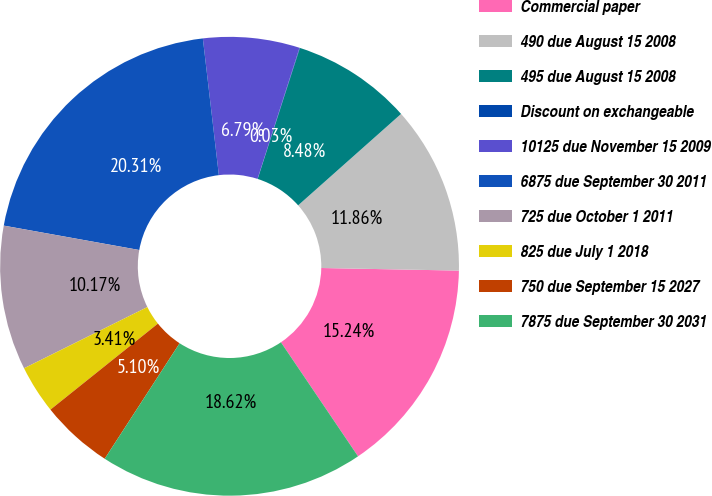<chart> <loc_0><loc_0><loc_500><loc_500><pie_chart><fcel>Commercial paper<fcel>490 due August 15 2008<fcel>495 due August 15 2008<fcel>Discount on exchangeable<fcel>10125 due November 15 2009<fcel>6875 due September 30 2011<fcel>725 due October 1 2011<fcel>825 due July 1 2018<fcel>750 due September 15 2027<fcel>7875 due September 30 2031<nl><fcel>15.24%<fcel>11.86%<fcel>8.48%<fcel>0.03%<fcel>6.79%<fcel>20.31%<fcel>10.17%<fcel>3.41%<fcel>5.1%<fcel>18.62%<nl></chart> 